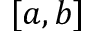Convert formula to latex. <formula><loc_0><loc_0><loc_500><loc_500>[ a , b ]</formula> 